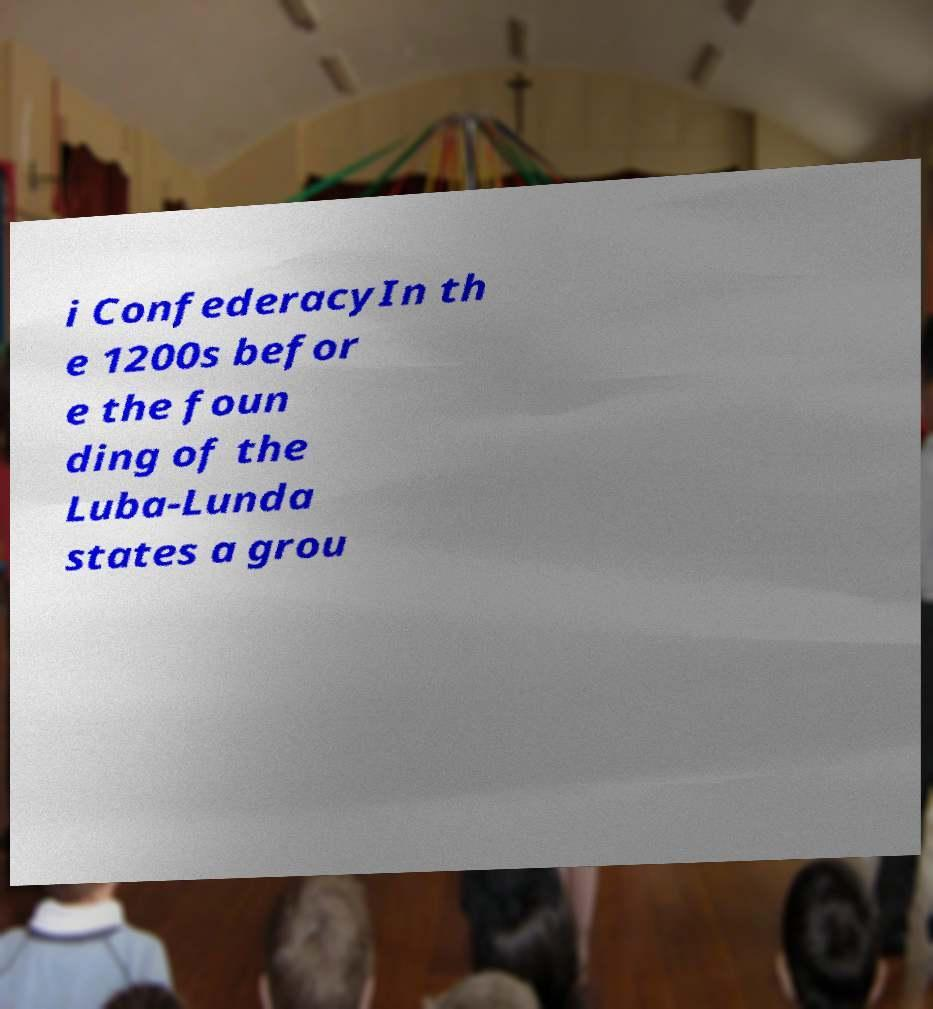Could you assist in decoding the text presented in this image and type it out clearly? i ConfederacyIn th e 1200s befor e the foun ding of the Luba-Lunda states a grou 